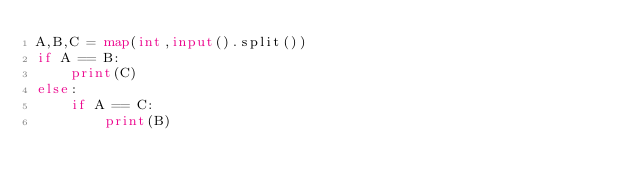Convert code to text. <code><loc_0><loc_0><loc_500><loc_500><_Python_>A,B,C = map(int,input().split())
if A == B:
    print(C)
else:
    if A == C:
        print(B)
        
</code> 